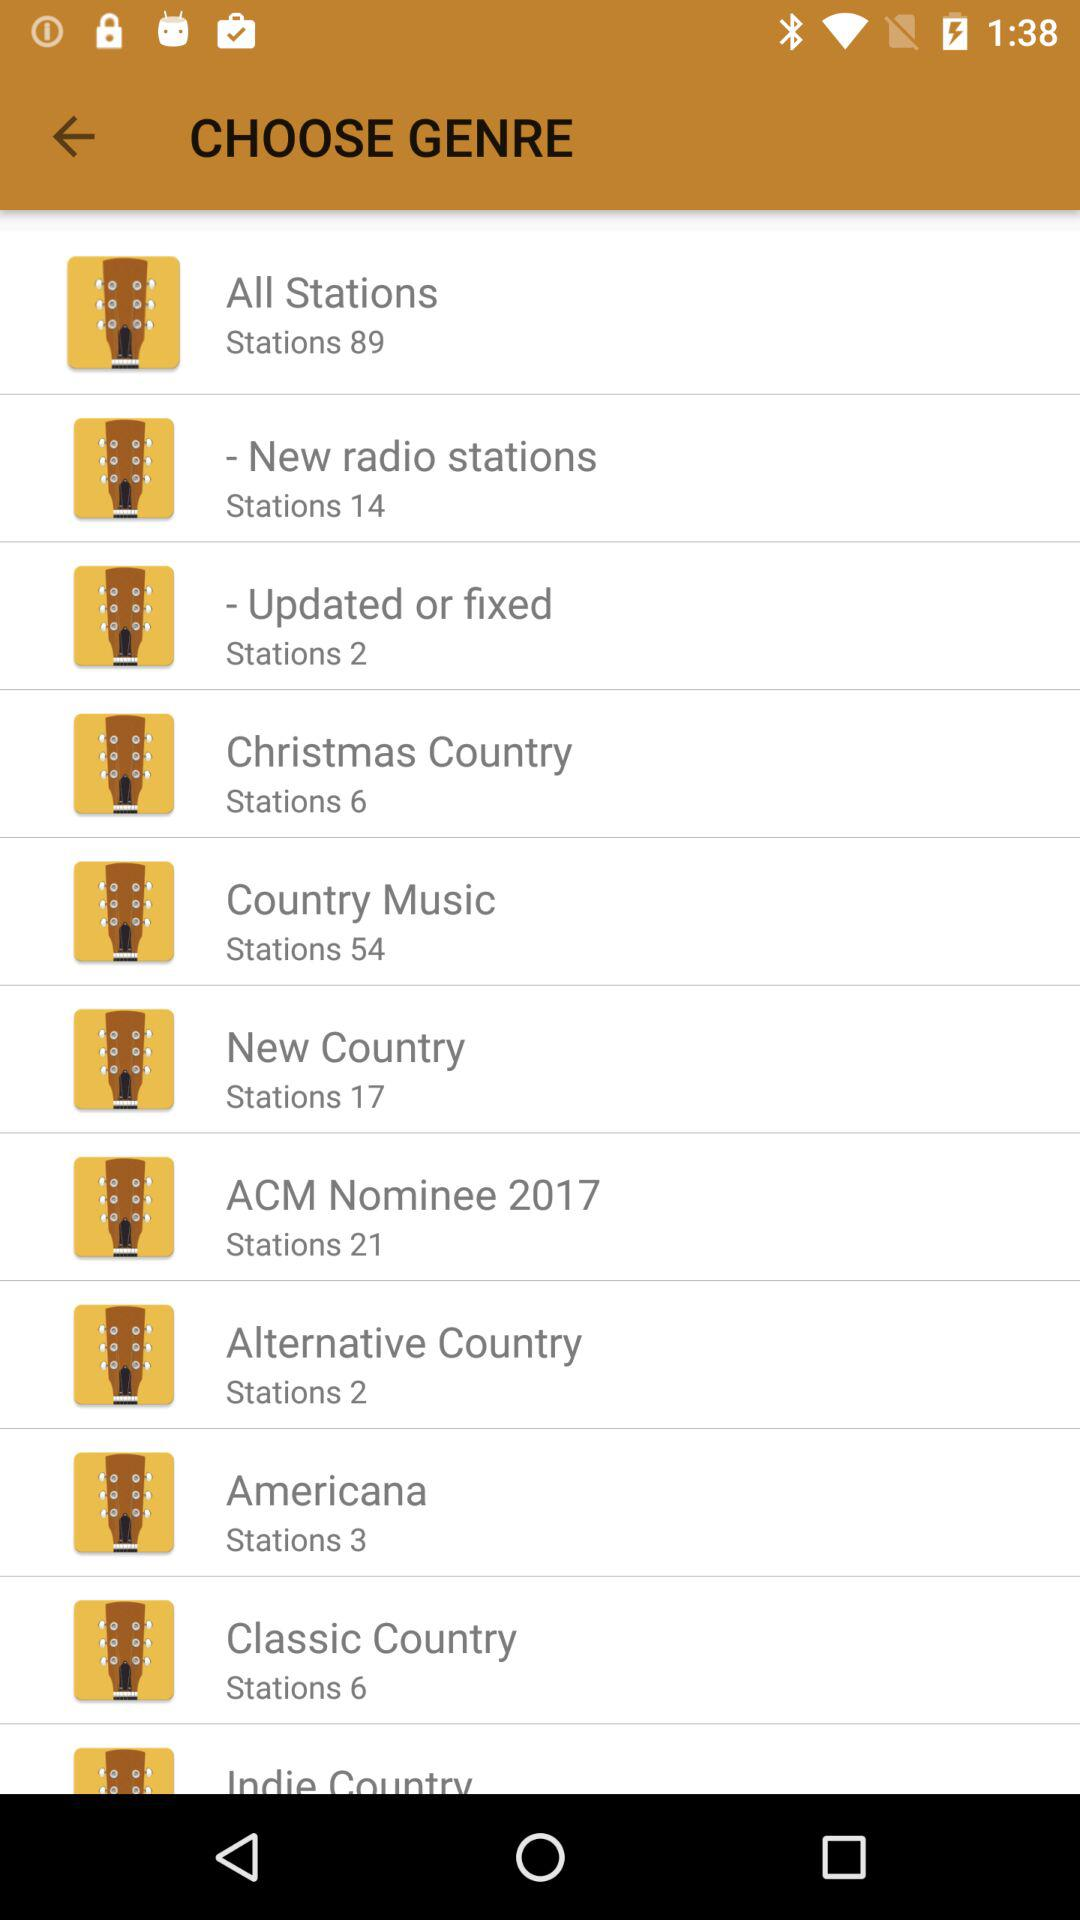How many stations are there in the "New Country" genre? There are 17 stations in the "New Country" genre. 